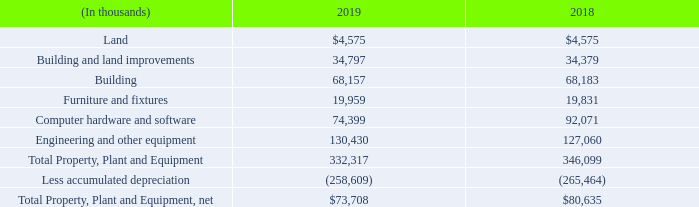Note 8 – Property, Plant and Equipment
As of December 31, 2019 and 2018, property, plant and equipment was comprised of the following:
Depreciation expense was $12.5 million, $12.7 million and $12.8 million for the years ended December 31, 2019, 2018 and 2017, respectively, which is recorded in cost of sales, selling, general and administrative expense and research and development expense in the consolidated statements of income.
We assess long-lived assets used in operations for potential impairment whenever events or changes in circumstances indicate that the carrying amount of an asset may not be recoverable and the undiscounted cash flows estimated to be generated by the asset are less than the asset’s carrying value. During the year ended December 31, 2019, the Company recognized impairment charges of $3.9 million related to the abandonment of certain information technology projects in which we had previously capitalized expenses related to these projects. The impairment charges were determined based on actual costs incurred as part of the projects. No impairment charges were recognized during the years ended December 31, 2018 and 2017.
What was the depreciation expense in 2019? $12.5 million. What was the  Total Property, Plant and Equipment, net in 2019?
Answer scale should be: thousand. $73,708. What was the amount of building assets in 2019?
Answer scale should be: thousand. 68,157. What was the change in furniture and fixtures between 2018 and 2019?
Answer scale should be: thousand. 19,959-19,831
Answer: 128. What was the change in engineering and other equipment between 2018 and 2019?
Answer scale should be: thousand. 130,430-127,060
Answer: 3370. What was the percentage change in net total property, plant and equipment between 2018 and 2019?
Answer scale should be: percent. ($73,708-$80,635)/$80,635
Answer: -8.59. 